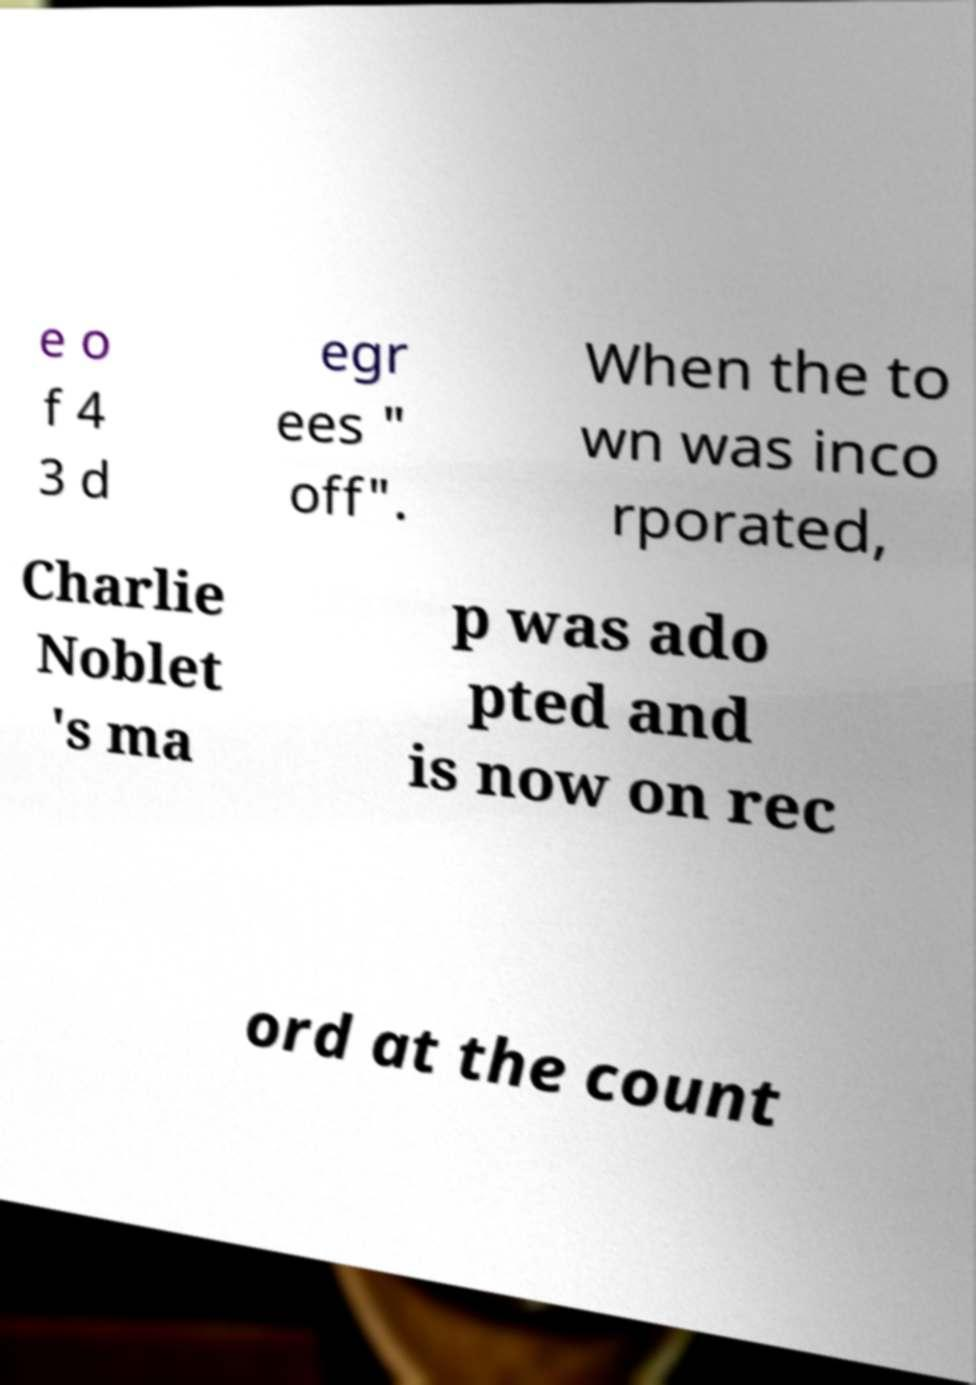Can you read and provide the text displayed in the image?This photo seems to have some interesting text. Can you extract and type it out for me? e o f 4 3 d egr ees " off". When the to wn was inco rporated, Charlie Noblet 's ma p was ado pted and is now on rec ord at the count 